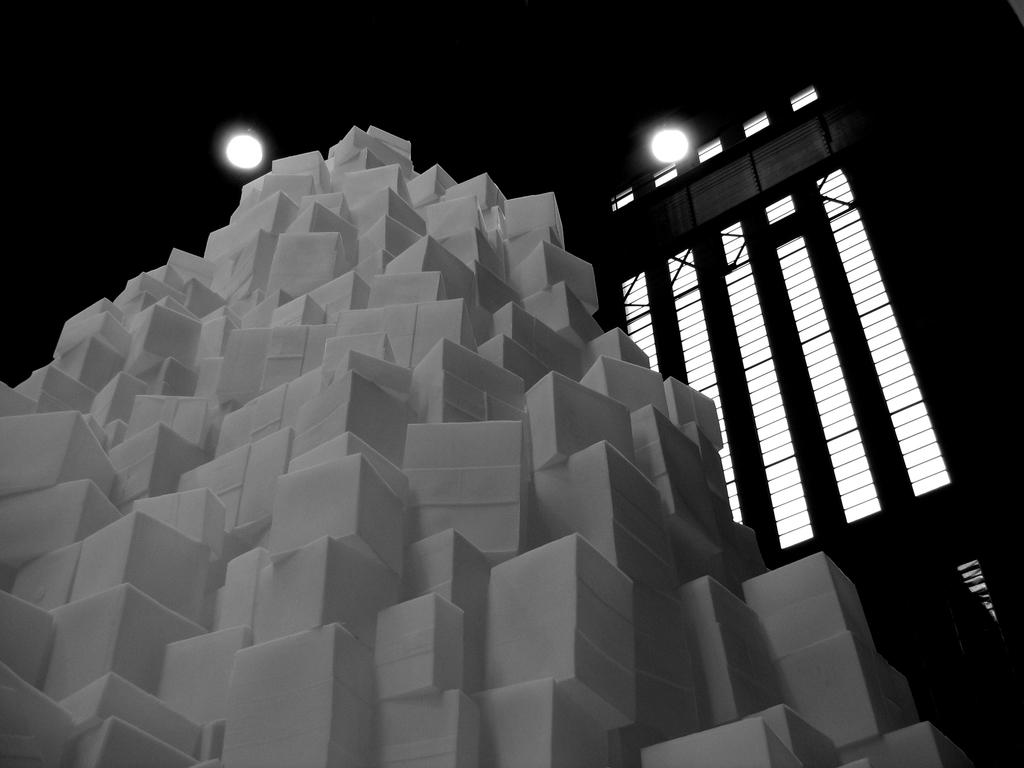What objects can be seen in the image? There are blocks, lights, and metal rods in the image. What is the color scheme of the image? The image is a black and white photography. What type of shoes can be seen in the image? There are no shoes present in the image. What is the weight of the objects on a scale in the image? There is no scale or any objects on a scale present in the image. 